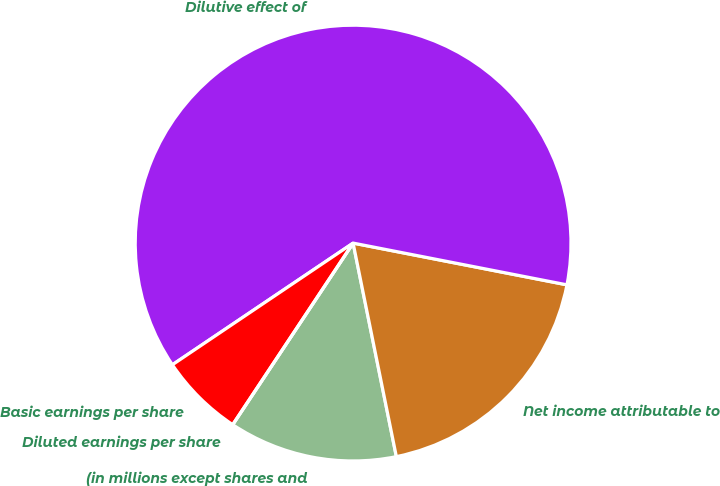Convert chart. <chart><loc_0><loc_0><loc_500><loc_500><pie_chart><fcel>(in millions except shares and<fcel>Net income attributable to<fcel>Dilutive effect of<fcel>Basic earnings per share<fcel>Diluted earnings per share<nl><fcel>12.5%<fcel>18.75%<fcel>62.5%<fcel>6.25%<fcel>0.0%<nl></chart> 